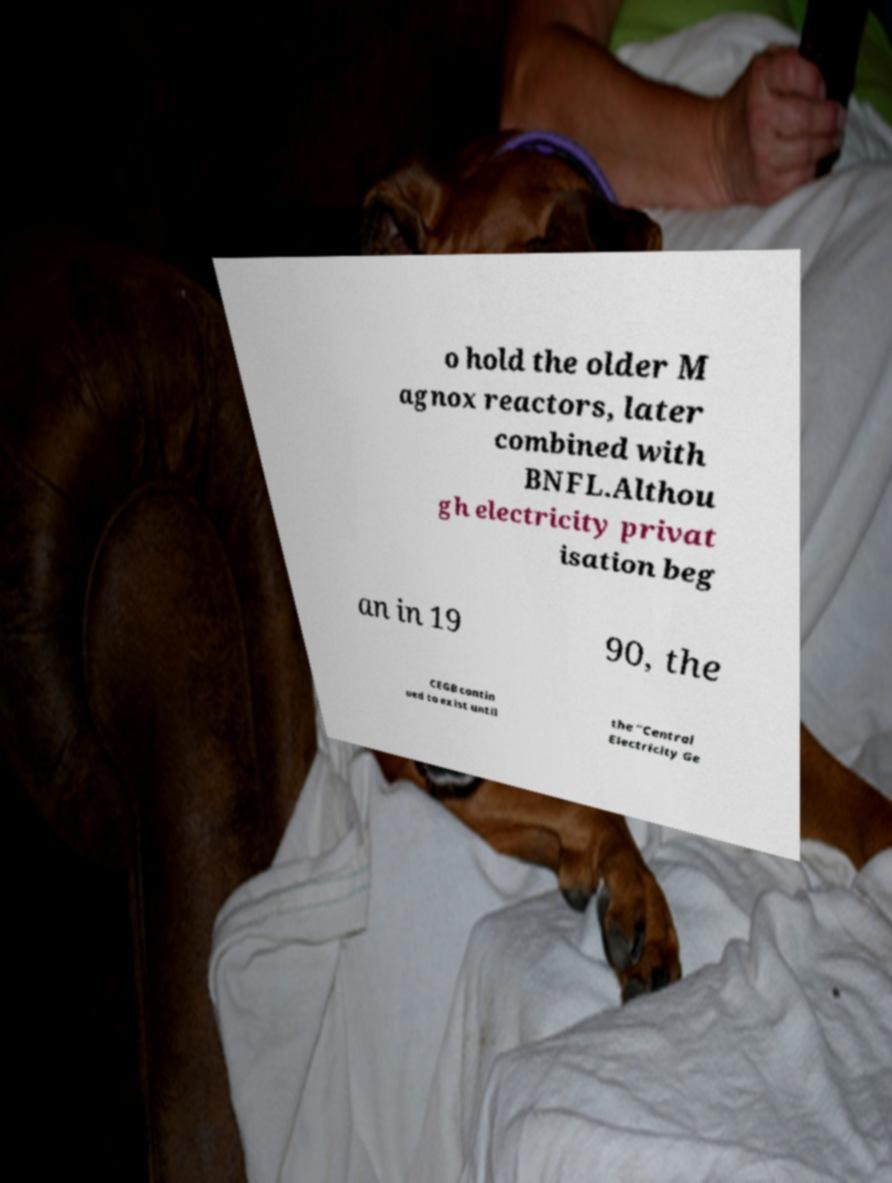I need the written content from this picture converted into text. Can you do that? o hold the older M agnox reactors, later combined with BNFL.Althou gh electricity privat isation beg an in 19 90, the CEGB contin ued to exist until the "Central Electricity Ge 